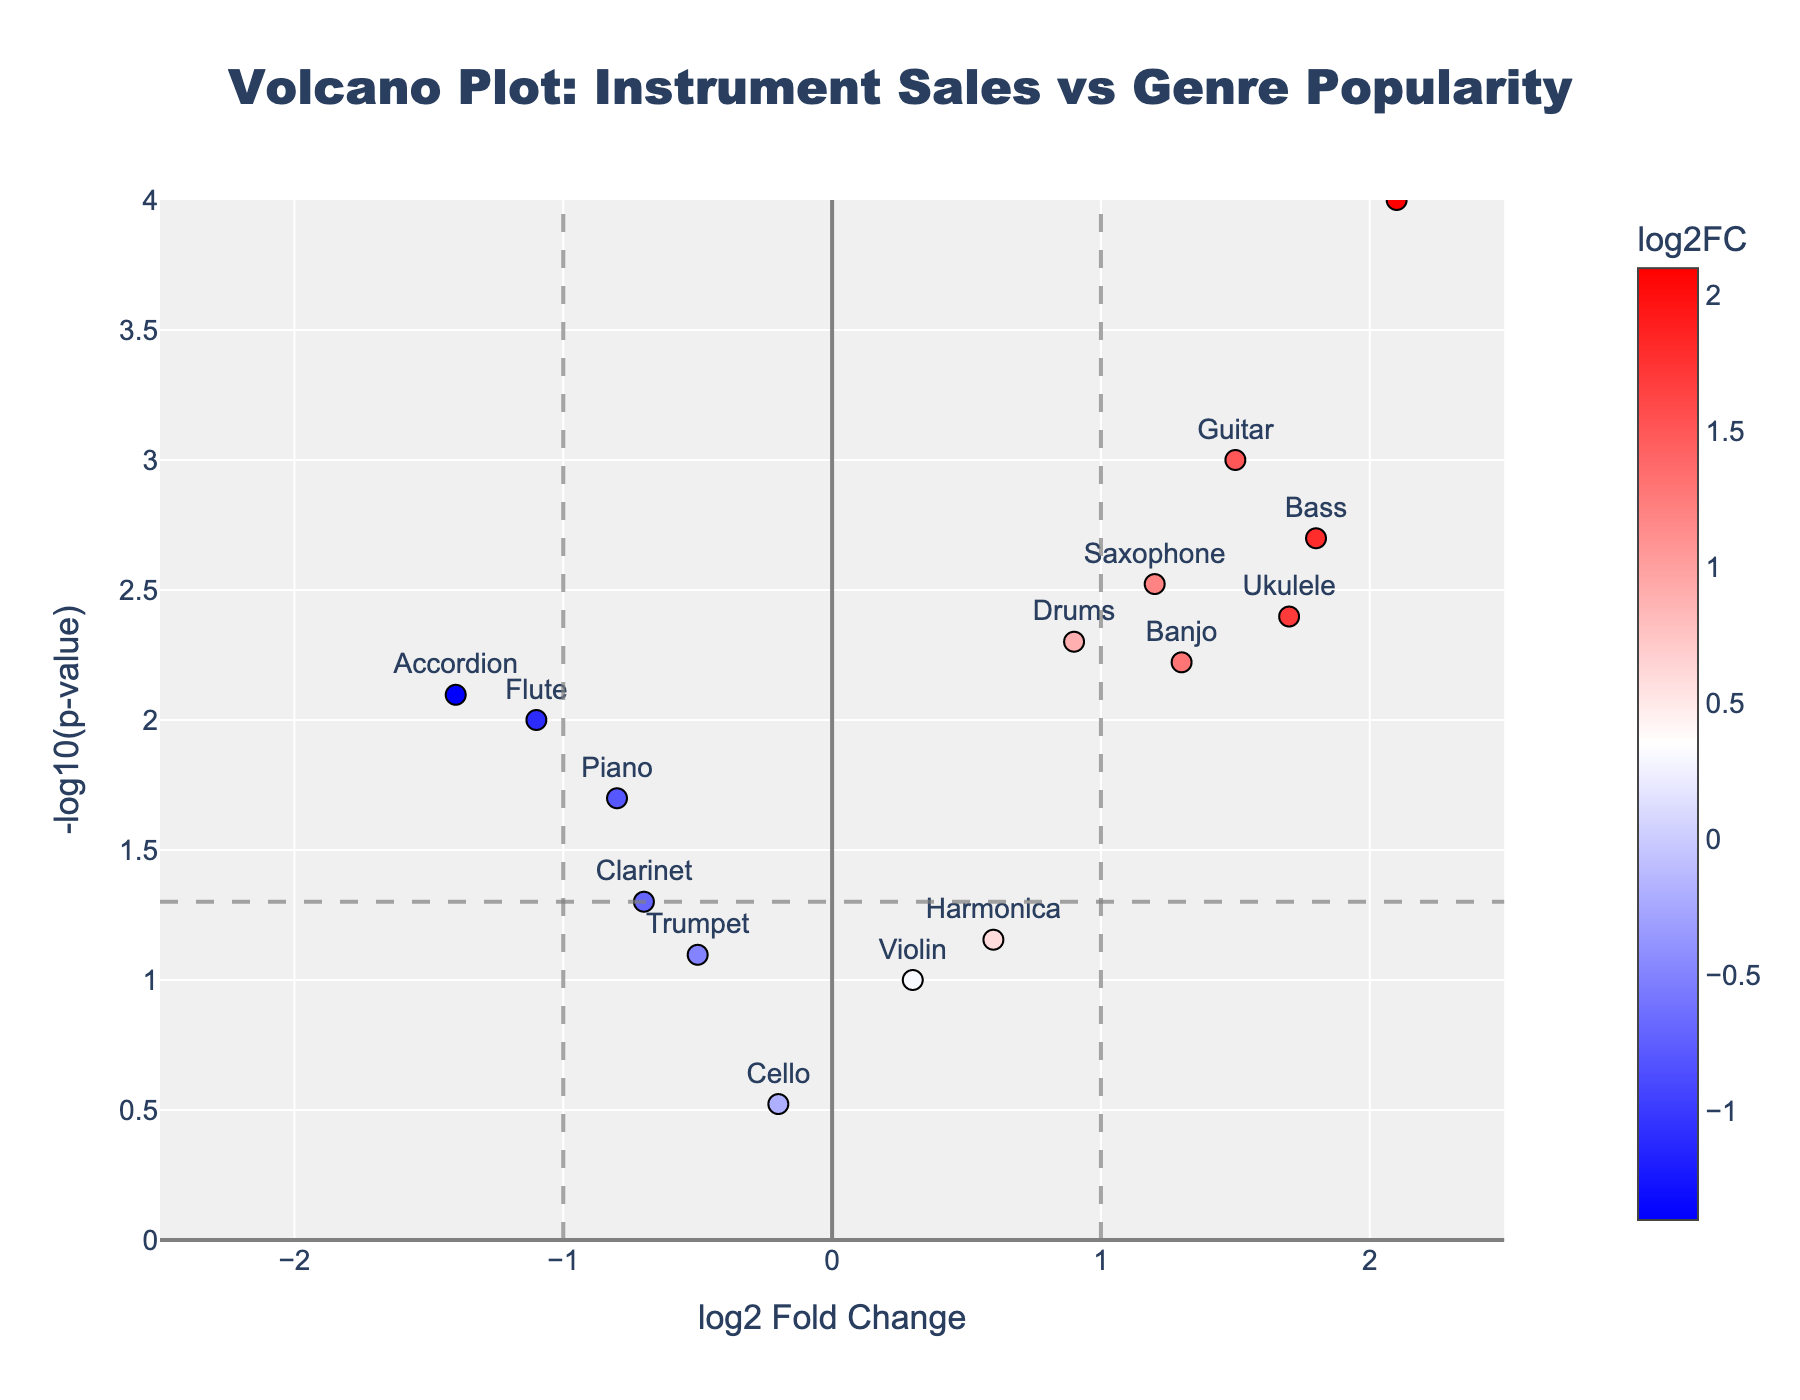What's the title of the figure? The title of the figure can be found at the top-center of the chart, specifying the content of the figure.
Answer: Volcano Plot: Instrument Sales vs Genre Popularity What's the y-axis label? The y-axis label is shown along the y-axis on the left side of the plot, indicating what the y-values represent.
Answer: -log10(p-value) Which instrument has the highest log2 Fold Change? Look for the point farthest to the right on the x-axis; this represents the highest log2FC. The text label will indicate the instrument's name.
Answer: Synthesizer Which instrument is associated with the lowest p-value? The lowest p-value corresponds to the highest y-value since the y-axis is -log10(p-value). Identify the point with the highest y-value and check the label.
Answer: Synthesizer Which genres are associated with more than one instrument in the plot? Identify repeated genre labels amongst the text labels corresponding to data points.
Answer: Classical and Jazz How many instruments have a log2 Fold Change greater than 1? Identify and count all the points positioned to the right of the 1 mark on the x-axis. Check the text labels for their respective instruments.
Answer: 5 (Guitar, Synthesizer, Bass, Ukulele, Banjo) What is the log2 Fold Change and p-value of the Flute? Locate the Flute label on the plot and read its corresponding x (log2FC) and y (-log10(p-value)) values. Convert -log10(p-value) back to p-value.
Answer: -1.1, 0.01 Which instrument in the Folk genre has a negative log2 Fold Change? Check for points labeled 'Folk' and identify which one has a negative x-coordinate (log2FC).
Answer: Accordion Is the Trumpet significantly different with respect to p-value threshold of 0.05? The p-value threshold of 0.05 corresponds to -log10(p-value) around 1.3 on the y-axis. Check if Trumpet is above this threshold line.
Answer: No 